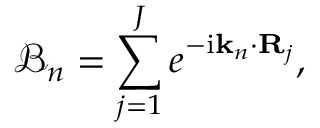Convert formula to latex. <formula><loc_0><loc_0><loc_500><loc_500>\mathcal { B } _ { n } = \sum _ { j = 1 } ^ { J } e ^ { - i k _ { n } \cdot R _ { j } } ,</formula> 